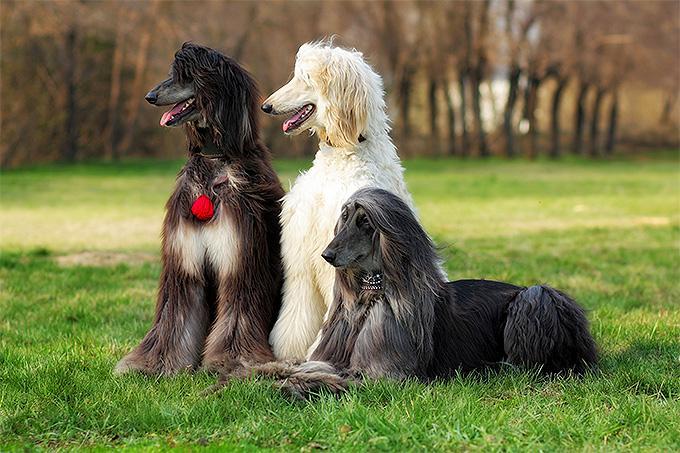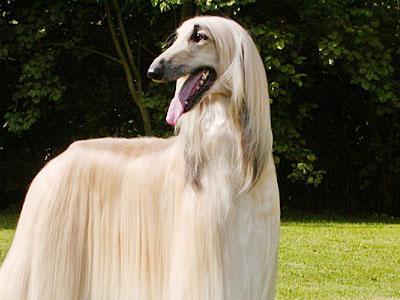The first image is the image on the left, the second image is the image on the right. Analyze the images presented: Is the assertion "There are no less than three dogs" valid? Answer yes or no. Yes. The first image is the image on the left, the second image is the image on the right. Evaluate the accuracy of this statement regarding the images: "Both dogs are facing the same direction.". Is it true? Answer yes or no. No. 